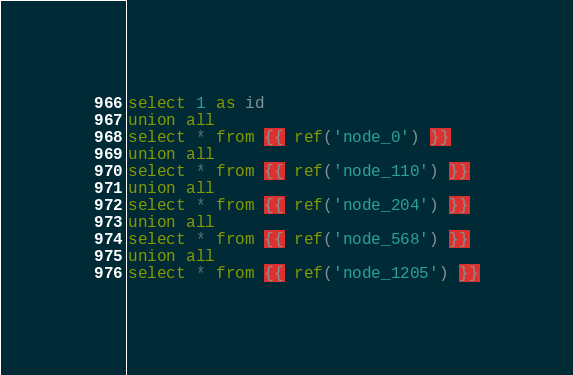Convert code to text. <code><loc_0><loc_0><loc_500><loc_500><_SQL_>select 1 as id
union all
select * from {{ ref('node_0') }}
union all
select * from {{ ref('node_110') }}
union all
select * from {{ ref('node_204') }}
union all
select * from {{ ref('node_568') }}
union all
select * from {{ ref('node_1205') }}</code> 